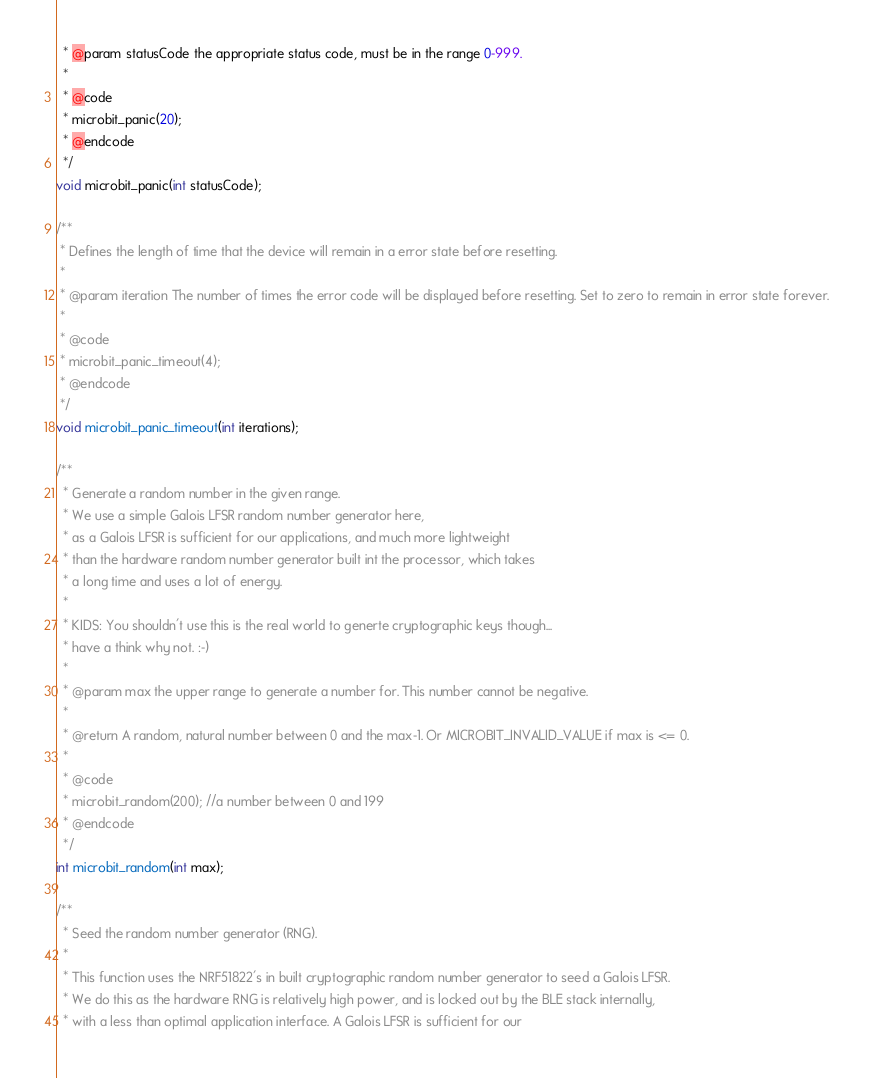<code> <loc_0><loc_0><loc_500><loc_500><_C_>  * @param statusCode the appropriate status code, must be in the range 0-999.
  *
  * @code
  * microbit_panic(20);
  * @endcode
  */
void microbit_panic(int statusCode);

/**
 * Defines the length of time that the device will remain in a error state before resetting.
 *
 * @param iteration The number of times the error code will be displayed before resetting. Set to zero to remain in error state forever.
 *
 * @code
 * microbit_panic_timeout(4);
 * @endcode
 */
void microbit_panic_timeout(int iterations);

/**
  * Generate a random number in the given range.
  * We use a simple Galois LFSR random number generator here,
  * as a Galois LFSR is sufficient for our applications, and much more lightweight
  * than the hardware random number generator built int the processor, which takes
  * a long time and uses a lot of energy.
  *
  * KIDS: You shouldn't use this is the real world to generte cryptographic keys though...
  * have a think why not. :-)
  *
  * @param max the upper range to generate a number for. This number cannot be negative.
  *
  * @return A random, natural number between 0 and the max-1. Or MICROBIT_INVALID_VALUE if max is <= 0.
  *
  * @code
  * microbit_random(200); //a number between 0 and 199
  * @endcode
  */
int microbit_random(int max);

/**
  * Seed the random number generator (RNG).
  *
  * This function uses the NRF51822's in built cryptographic random number generator to seed a Galois LFSR.
  * We do this as the hardware RNG is relatively high power, and is locked out by the BLE stack internally,
  * with a less than optimal application interface. A Galois LFSR is sufficient for our</code> 